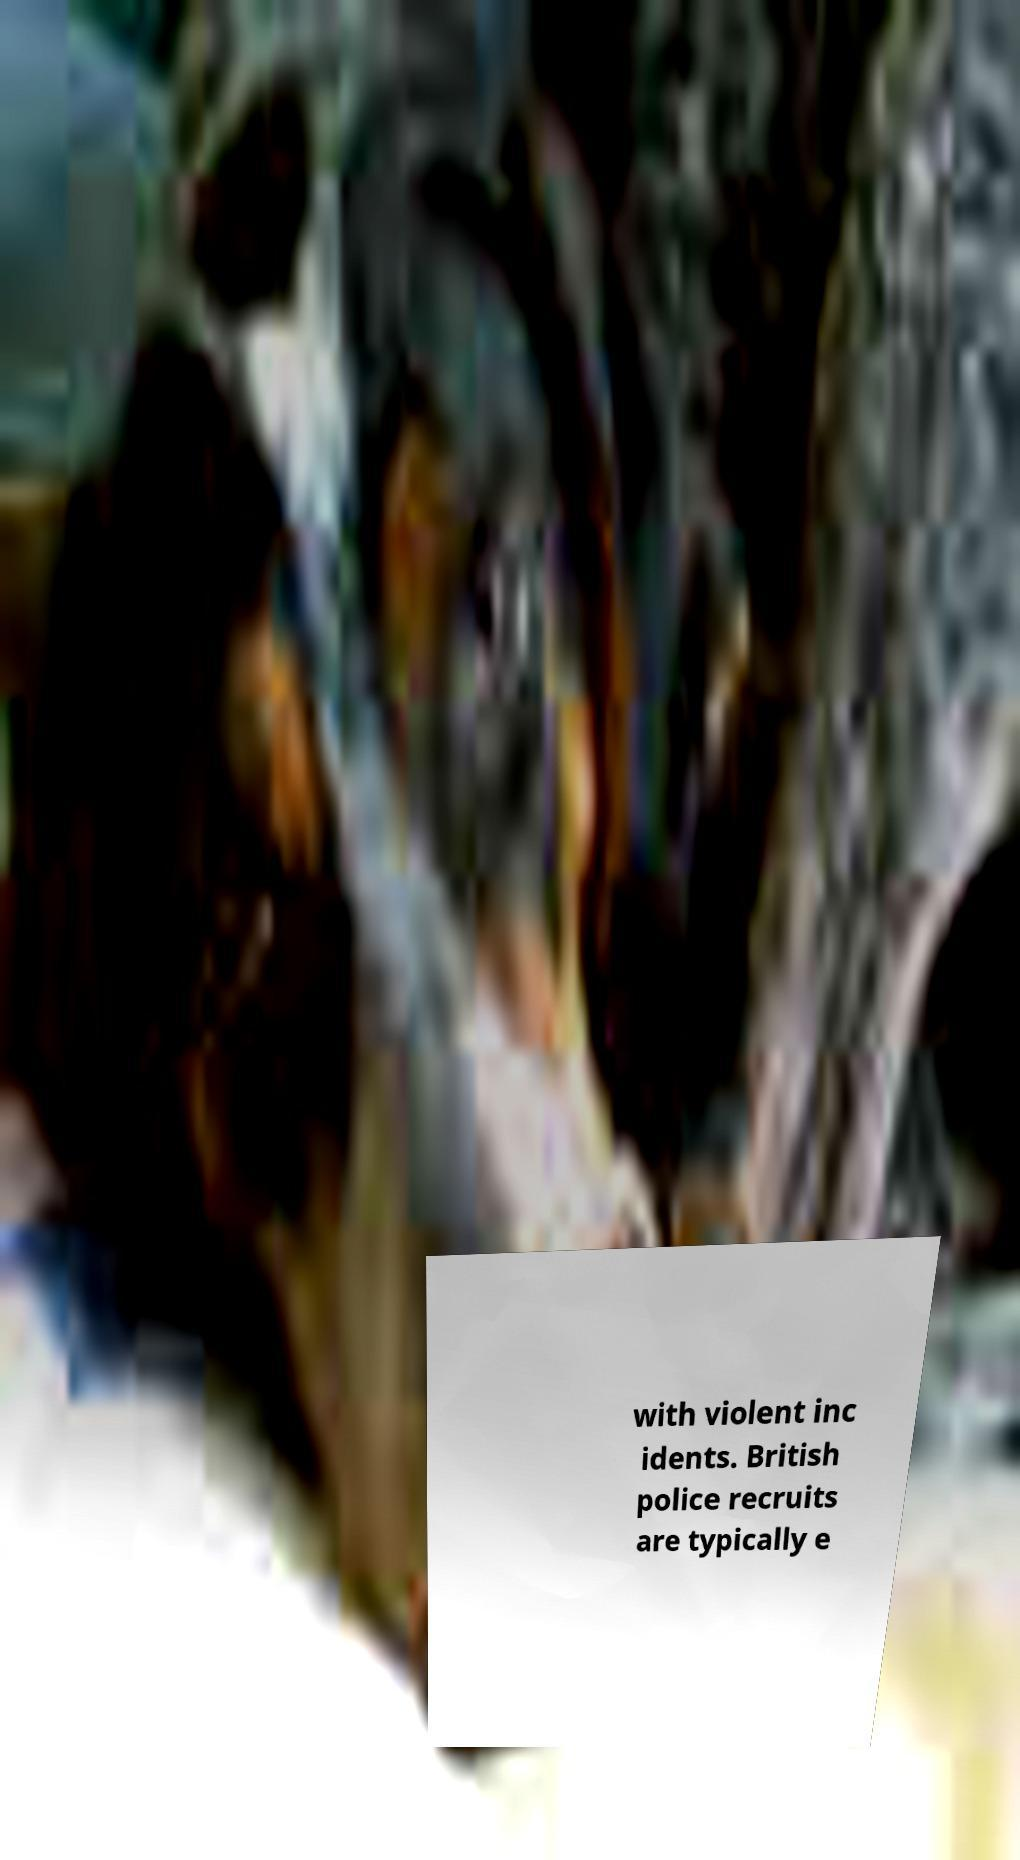For documentation purposes, I need the text within this image transcribed. Could you provide that? with violent inc idents. British police recruits are typically e 